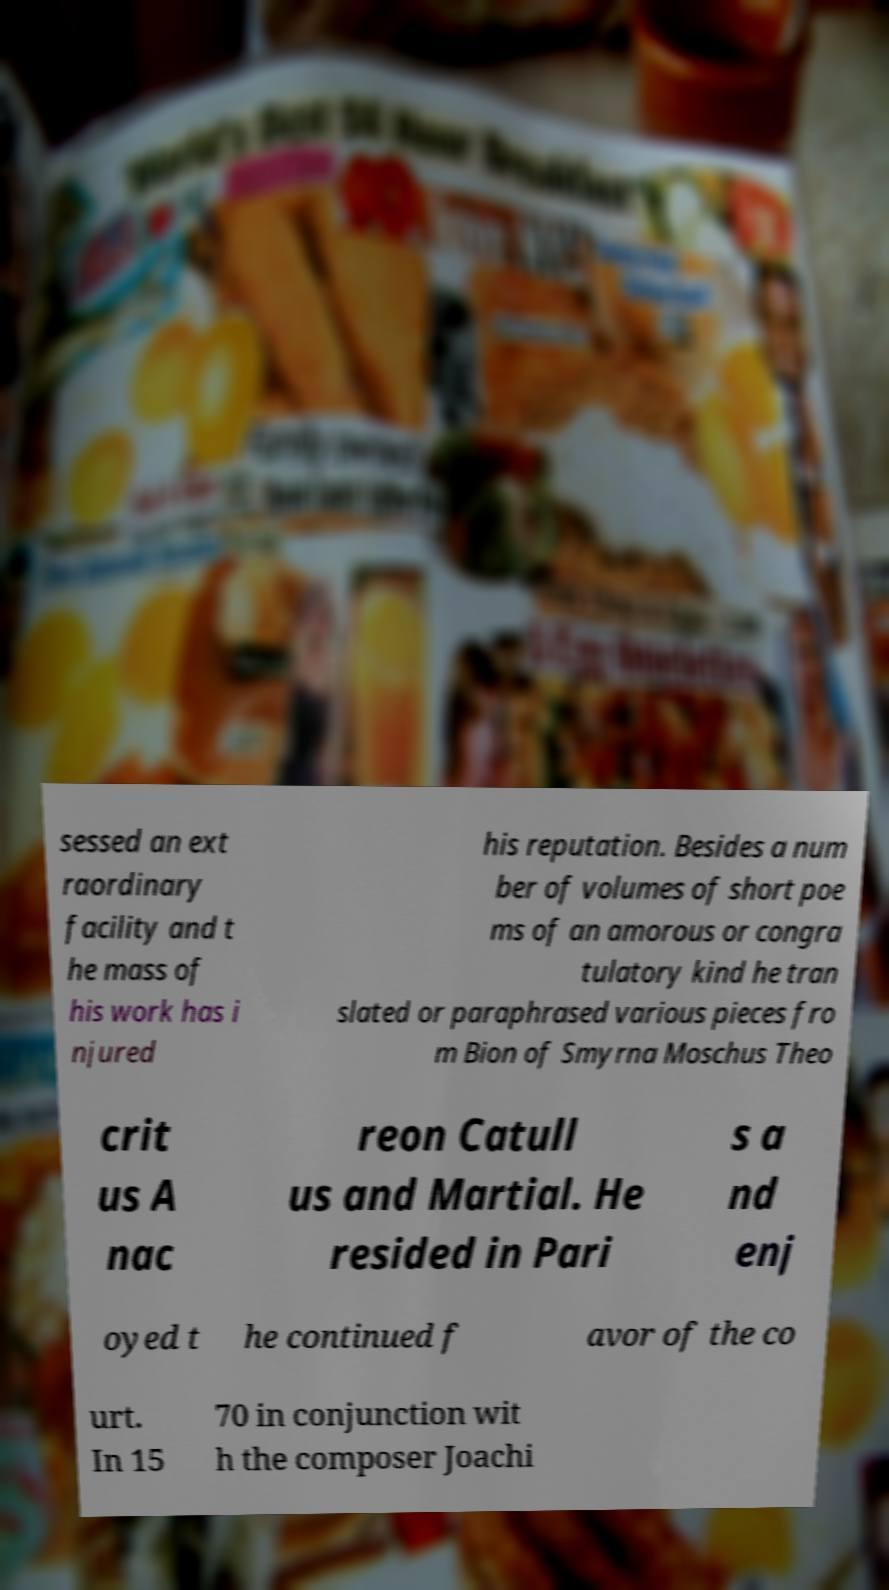There's text embedded in this image that I need extracted. Can you transcribe it verbatim? sessed an ext raordinary facility and t he mass of his work has i njured his reputation. Besides a num ber of volumes of short poe ms of an amorous or congra tulatory kind he tran slated or paraphrased various pieces fro m Bion of Smyrna Moschus Theo crit us A nac reon Catull us and Martial. He resided in Pari s a nd enj oyed t he continued f avor of the co urt. In 15 70 in conjunction wit h the composer Joachi 